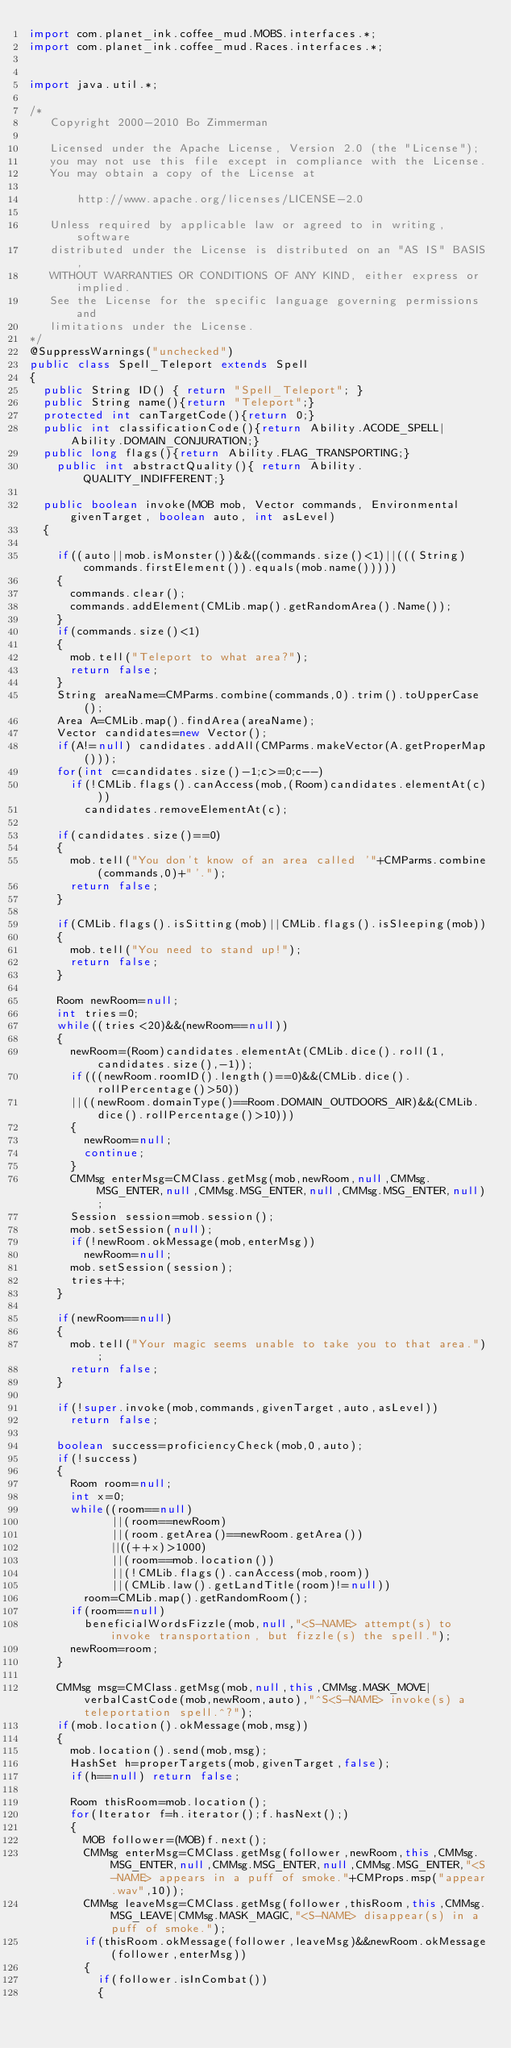<code> <loc_0><loc_0><loc_500><loc_500><_Java_>import com.planet_ink.coffee_mud.MOBS.interfaces.*;
import com.planet_ink.coffee_mud.Races.interfaces.*;


import java.util.*;

/* 
   Copyright 2000-2010 Bo Zimmerman

   Licensed under the Apache License, Version 2.0 (the "License");
   you may not use this file except in compliance with the License.
   You may obtain a copy of the License at

       http://www.apache.org/licenses/LICENSE-2.0

   Unless required by applicable law or agreed to in writing, software
   distributed under the License is distributed on an "AS IS" BASIS,
   WITHOUT WARRANTIES OR CONDITIONS OF ANY KIND, either express or implied.
   See the License for the specific language governing permissions and
   limitations under the License.
*/
@SuppressWarnings("unchecked")
public class Spell_Teleport extends Spell
{
	public String ID() { return "Spell_Teleport"; }
	public String name(){return "Teleport";}
	protected int canTargetCode(){return 0;}
	public int classificationCode(){return Ability.ACODE_SPELL|Ability.DOMAIN_CONJURATION;}
	public long flags(){return Ability.FLAG_TRANSPORTING;}
    public int abstractQuality(){ return Ability.QUALITY_INDIFFERENT;}

	public boolean invoke(MOB mob, Vector commands, Environmental givenTarget, boolean auto, int asLevel)
	{

		if((auto||mob.isMonster())&&((commands.size()<1)||(((String)commands.firstElement()).equals(mob.name()))))
		{
			commands.clear();
			commands.addElement(CMLib.map().getRandomArea().Name());
		}
		if(commands.size()<1)
		{
			mob.tell("Teleport to what area?");
			return false;
		}
		String areaName=CMParms.combine(commands,0).trim().toUpperCase();
		Area A=CMLib.map().findArea(areaName);
		Vector candidates=new Vector();
		if(A!=null) candidates.addAll(CMParms.makeVector(A.getProperMap()));
		for(int c=candidates.size()-1;c>=0;c--)
			if(!CMLib.flags().canAccess(mob,(Room)candidates.elementAt(c)))
				candidates.removeElementAt(c);

		if(candidates.size()==0)
		{
			mob.tell("You don't know of an area called '"+CMParms.combine(commands,0)+"'.");
			return false;
		}

		if(CMLib.flags().isSitting(mob)||CMLib.flags().isSleeping(mob))
		{
			mob.tell("You need to stand up!");
			return false;
		}

		Room newRoom=null;
		int tries=0;
		while((tries<20)&&(newRoom==null))
		{
			newRoom=(Room)candidates.elementAt(CMLib.dice().roll(1,candidates.size(),-1));
			if(((newRoom.roomID().length()==0)&&(CMLib.dice().rollPercentage()>50))
			||((newRoom.domainType()==Room.DOMAIN_OUTDOORS_AIR)&&(CMLib.dice().rollPercentage()>10)))
			{
				newRoom=null;
				continue;
			}
			CMMsg enterMsg=CMClass.getMsg(mob,newRoom,null,CMMsg.MSG_ENTER,null,CMMsg.MSG_ENTER,null,CMMsg.MSG_ENTER,null);
			Session session=mob.session();
			mob.setSession(null);
			if(!newRoom.okMessage(mob,enterMsg))
				newRoom=null;
			mob.setSession(session);
			tries++;
		}

		if(newRoom==null)
		{
			mob.tell("Your magic seems unable to take you to that area.");
			return false;
		}

		if(!super.invoke(mob,commands,givenTarget,auto,asLevel))
			return false;

		boolean success=proficiencyCheck(mob,0,auto);
		if(!success)
		{
			Room room=null;
			int x=0;
			while((room==null)
            ||(room==newRoom)
            ||(room.getArea()==newRoom.getArea())
            ||((++x)>1000)
            ||(room==mob.location())
            ||(!CMLib.flags().canAccess(mob,room))
            ||(CMLib.law().getLandTitle(room)!=null))
				room=CMLib.map().getRandomRoom();
			if(room==null)
				beneficialWordsFizzle(mob,null,"<S-NAME> attempt(s) to invoke transportation, but fizzle(s) the spell.");
			newRoom=room;
		}

		CMMsg msg=CMClass.getMsg(mob,null,this,CMMsg.MASK_MOVE|verbalCastCode(mob,newRoom,auto),"^S<S-NAME> invoke(s) a teleportation spell.^?");
		if(mob.location().okMessage(mob,msg))
		{
			mob.location().send(mob,msg);
			HashSet h=properTargets(mob,givenTarget,false);
			if(h==null) return false;

			Room thisRoom=mob.location();
			for(Iterator f=h.iterator();f.hasNext();)
			{
				MOB follower=(MOB)f.next();
				CMMsg enterMsg=CMClass.getMsg(follower,newRoom,this,CMMsg.MSG_ENTER,null,CMMsg.MSG_ENTER,null,CMMsg.MSG_ENTER,"<S-NAME> appears in a puff of smoke."+CMProps.msp("appear.wav",10));
				CMMsg leaveMsg=CMClass.getMsg(follower,thisRoom,this,CMMsg.MSG_LEAVE|CMMsg.MASK_MAGIC,"<S-NAME> disappear(s) in a puff of smoke.");
				if(thisRoom.okMessage(follower,leaveMsg)&&newRoom.okMessage(follower,enterMsg))
				{
					if(follower.isInCombat())
					{</code> 